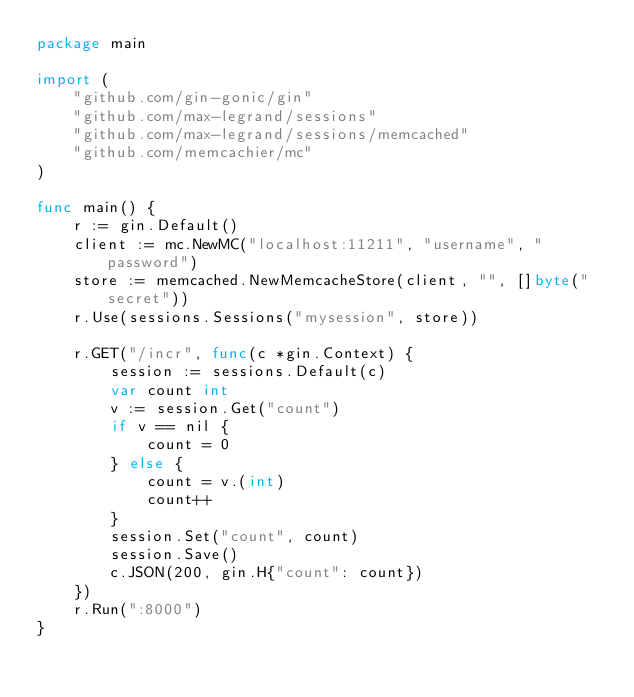<code> <loc_0><loc_0><loc_500><loc_500><_Go_>package main

import (
	"github.com/gin-gonic/gin"
	"github.com/max-legrand/sessions"
	"github.com/max-legrand/sessions/memcached"
	"github.com/memcachier/mc"
)

func main() {
	r := gin.Default()
	client := mc.NewMC("localhost:11211", "username", "password")
	store := memcached.NewMemcacheStore(client, "", []byte("secret"))
	r.Use(sessions.Sessions("mysession", store))

	r.GET("/incr", func(c *gin.Context) {
		session := sessions.Default(c)
		var count int
		v := session.Get("count")
		if v == nil {
			count = 0
		} else {
			count = v.(int)
			count++
		}
		session.Set("count", count)
		session.Save()
		c.JSON(200, gin.H{"count": count})
	})
	r.Run(":8000")
}
</code> 